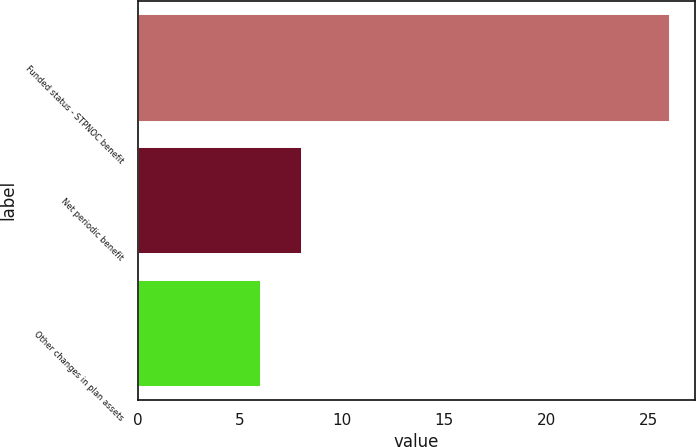Convert chart to OTSL. <chart><loc_0><loc_0><loc_500><loc_500><bar_chart><fcel>Funded status - STPNOC benefit<fcel>Net periodic benefit<fcel>Other changes in plan assets<nl><fcel>26<fcel>8<fcel>6<nl></chart> 